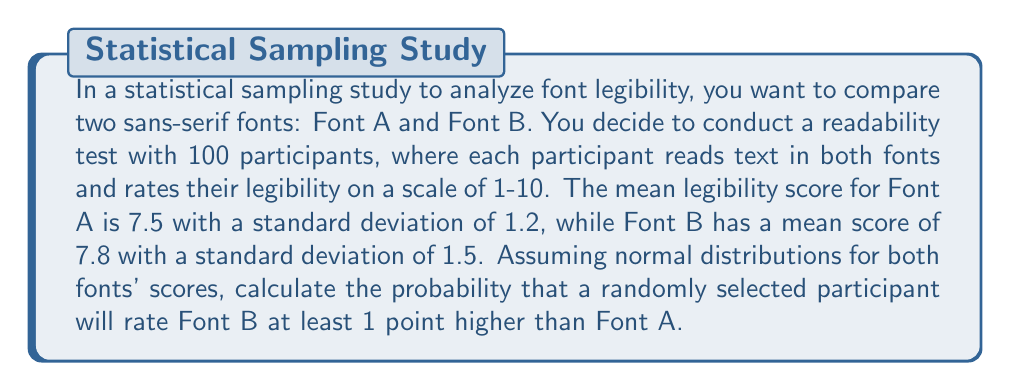Solve this math problem. To solve this problem, we'll follow these steps:

1. Define the random variables:
   Let $X_A$ be the score for Font A and $X_B$ be the score for Font B.

2. Given information:
   $X_A \sim N(\mu_A = 7.5, \sigma_A = 1.2)$
   $X_B \sim N(\mu_B = 7.8, \sigma_B = 1.5)$

3. We need to find $P(X_B - X_A \geq 1)$

4. The difference between two normally distributed random variables is also normally distributed:
   $X_B - X_A \sim N(\mu_B - \mu_A, \sqrt{\sigma_A^2 + \sigma_B^2})$

5. Calculate the mean and standard deviation of the difference:
   $\mu_{B-A} = \mu_B - \mu_A = 7.8 - 7.5 = 0.3$
   $\sigma_{B-A} = \sqrt{\sigma_A^2 + \sigma_B^2} = \sqrt{1.2^2 + 1.5^2} = \sqrt{3.69} \approx 1.92$

6. Standardize the difference:
   $Z = \frac{(X_B - X_A) - \mu_{B-A}}{\sigma_{B-A}} = \frac{1 - 0.3}{1.92} \approx 0.365$

7. Use the standard normal distribution to find the probability:
   $P(X_B - X_A \geq 1) = P(Z \geq 0.365) = 1 - \Phi(0.365)$

   Where $\Phi(z)$ is the cumulative distribution function of the standard normal distribution.

8. Using a standard normal table or calculator:
   $1 - \Phi(0.365) \approx 0.3576$

Therefore, the probability that a randomly selected participant will rate Font B at least 1 point higher than Font A is approximately 0.3576 or 35.76%.
Answer: 0.3576 